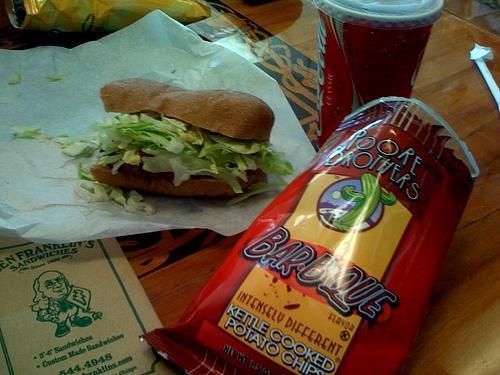How many cups?
Give a very brief answer. 1. How many bird legs can you see in this picture?
Give a very brief answer. 0. 